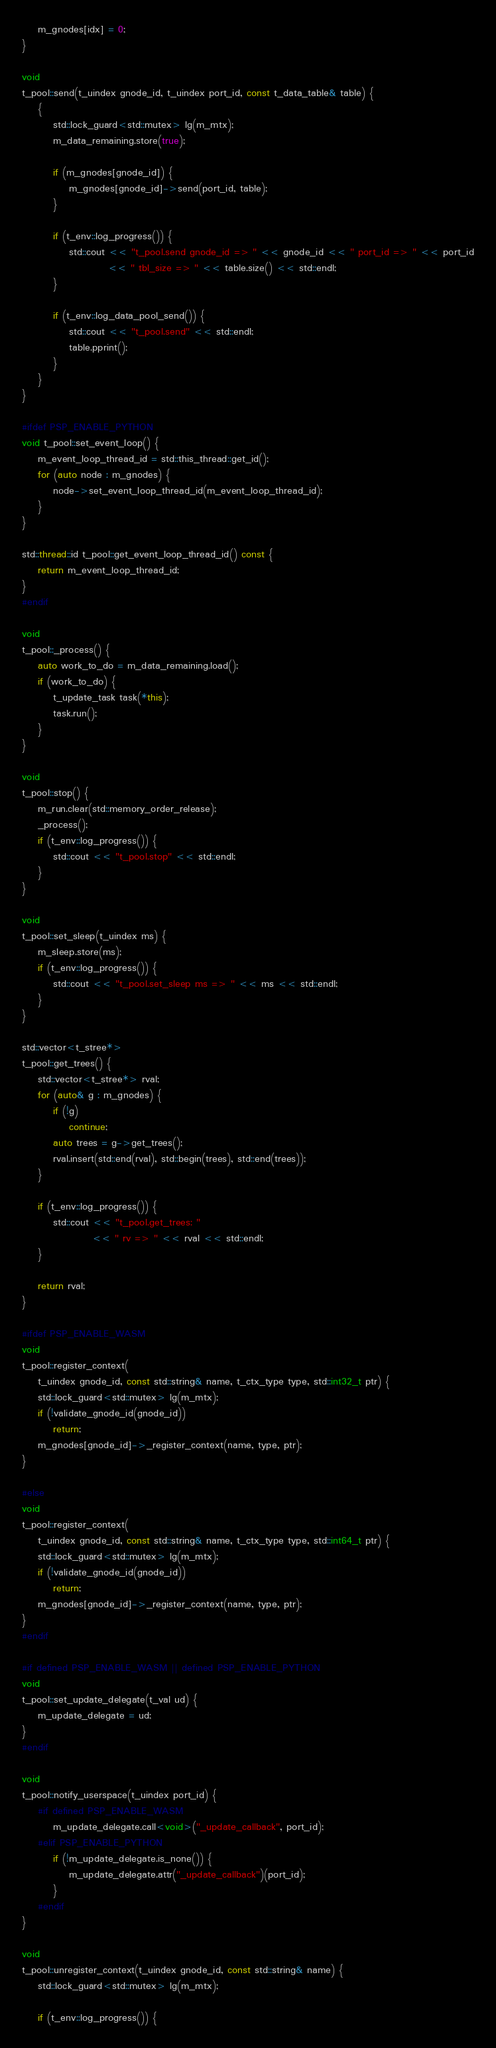<code> <loc_0><loc_0><loc_500><loc_500><_C++_>    m_gnodes[idx] = 0;
}

void
t_pool::send(t_uindex gnode_id, t_uindex port_id, const t_data_table& table) {
    {
        std::lock_guard<std::mutex> lg(m_mtx);
        m_data_remaining.store(true);

        if (m_gnodes[gnode_id]) {
            m_gnodes[gnode_id]->send(port_id, table);
        }

        if (t_env::log_progress()) {
            std::cout << "t_pool.send gnode_id => " << gnode_id << " port_id => " << port_id
                      << " tbl_size => " << table.size() << std::endl;
        }

        if (t_env::log_data_pool_send()) {
            std::cout << "t_pool.send" << std::endl;
            table.pprint();
        }
    }
}

#ifdef PSP_ENABLE_PYTHON
void t_pool::set_event_loop() {
    m_event_loop_thread_id = std::this_thread::get_id();
    for (auto node : m_gnodes) {
        node->set_event_loop_thread_id(m_event_loop_thread_id);
    }
}

std::thread::id t_pool::get_event_loop_thread_id() const {
    return m_event_loop_thread_id;
}
#endif

void
t_pool::_process() {
    auto work_to_do = m_data_remaining.load();
    if (work_to_do) {
        t_update_task task(*this);
        task.run();
    }
}

void
t_pool::stop() {
    m_run.clear(std::memory_order_release);
    _process();
    if (t_env::log_progress()) {
        std::cout << "t_pool.stop" << std::endl;
    }
}

void
t_pool::set_sleep(t_uindex ms) {
    m_sleep.store(ms);
    if (t_env::log_progress()) {
        std::cout << "t_pool.set_sleep ms => " << ms << std::endl;
    }
}

std::vector<t_stree*>
t_pool::get_trees() {
    std::vector<t_stree*> rval;
    for (auto& g : m_gnodes) {
        if (!g)
            continue;
        auto trees = g->get_trees();
        rval.insert(std::end(rval), std::begin(trees), std::end(trees));
    }

    if (t_env::log_progress()) {
        std::cout << "t_pool.get_trees: "
                  << " rv => " << rval << std::endl;
    }

    return rval;
}

#ifdef PSP_ENABLE_WASM
void
t_pool::register_context(
    t_uindex gnode_id, const std::string& name, t_ctx_type type, std::int32_t ptr) {
    std::lock_guard<std::mutex> lg(m_mtx);
    if (!validate_gnode_id(gnode_id))
        return;
    m_gnodes[gnode_id]->_register_context(name, type, ptr);
}

#else
void
t_pool::register_context(
    t_uindex gnode_id, const std::string& name, t_ctx_type type, std::int64_t ptr) {
    std::lock_guard<std::mutex> lg(m_mtx);
    if (!validate_gnode_id(gnode_id))
        return;
    m_gnodes[gnode_id]->_register_context(name, type, ptr);
}
#endif

#if defined PSP_ENABLE_WASM || defined PSP_ENABLE_PYTHON
void
t_pool::set_update_delegate(t_val ud) {
    m_update_delegate = ud;
}
#endif

void
t_pool::notify_userspace(t_uindex port_id) {
    #if defined PSP_ENABLE_WASM
        m_update_delegate.call<void>("_update_callback", port_id);
    #elif PSP_ENABLE_PYTHON
        if (!m_update_delegate.is_none()) {
            m_update_delegate.attr("_update_callback")(port_id);
        }
    #endif
}

void
t_pool::unregister_context(t_uindex gnode_id, const std::string& name) {
    std::lock_guard<std::mutex> lg(m_mtx);

    if (t_env::log_progress()) {</code> 